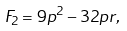<formula> <loc_0><loc_0><loc_500><loc_500>F _ { 2 } = 9 p ^ { 2 } - 3 2 p r ,</formula> 